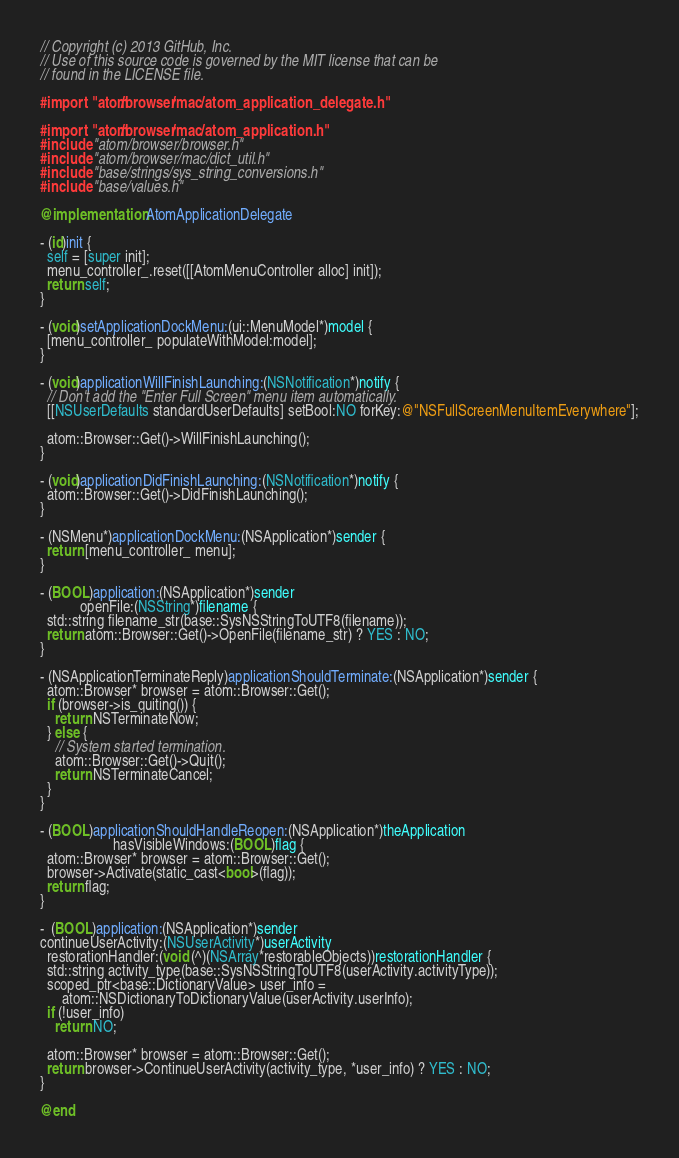<code> <loc_0><loc_0><loc_500><loc_500><_ObjectiveC_>// Copyright (c) 2013 GitHub, Inc.
// Use of this source code is governed by the MIT license that can be
// found in the LICENSE file.

#import "atom/browser/mac/atom_application_delegate.h"

#import "atom/browser/mac/atom_application.h"
#include "atom/browser/browser.h"
#include "atom/browser/mac/dict_util.h"
#include "base/strings/sys_string_conversions.h"
#include "base/values.h"

@implementation AtomApplicationDelegate

- (id)init {
  self = [super init];
  menu_controller_.reset([[AtomMenuController alloc] init]);
  return self;
}

- (void)setApplicationDockMenu:(ui::MenuModel*)model {
  [menu_controller_ populateWithModel:model];
}

- (void)applicationWillFinishLaunching:(NSNotification*)notify {
  // Don't add the "Enter Full Screen" menu item automatically.
  [[NSUserDefaults standardUserDefaults] setBool:NO forKey:@"NSFullScreenMenuItemEverywhere"];

  atom::Browser::Get()->WillFinishLaunching();
}

- (void)applicationDidFinishLaunching:(NSNotification*)notify {
  atom::Browser::Get()->DidFinishLaunching();
}

- (NSMenu*)applicationDockMenu:(NSApplication*)sender {
  return [menu_controller_ menu];
}

- (BOOL)application:(NSApplication*)sender
           openFile:(NSString*)filename {
  std::string filename_str(base::SysNSStringToUTF8(filename));
  return atom::Browser::Get()->OpenFile(filename_str) ? YES : NO;
}

- (NSApplicationTerminateReply)applicationShouldTerminate:(NSApplication*)sender {
  atom::Browser* browser = atom::Browser::Get();
  if (browser->is_quiting()) {
    return NSTerminateNow;
  } else {
    // System started termination.
    atom::Browser::Get()->Quit();
    return NSTerminateCancel;
  }
}

- (BOOL)applicationShouldHandleReopen:(NSApplication*)theApplication
                    hasVisibleWindows:(BOOL)flag {
  atom::Browser* browser = atom::Browser::Get();
  browser->Activate(static_cast<bool>(flag));
  return flag;
}

-  (BOOL)application:(NSApplication*)sender
continueUserActivity:(NSUserActivity*)userActivity
  restorationHandler:(void (^)(NSArray*restorableObjects))restorationHandler {
  std::string activity_type(base::SysNSStringToUTF8(userActivity.activityType));
  scoped_ptr<base::DictionaryValue> user_info =
      atom::NSDictionaryToDictionaryValue(userActivity.userInfo);
  if (!user_info)
    return NO;

  atom::Browser* browser = atom::Browser::Get();
  return browser->ContinueUserActivity(activity_type, *user_info) ? YES : NO;
}

@end
</code> 